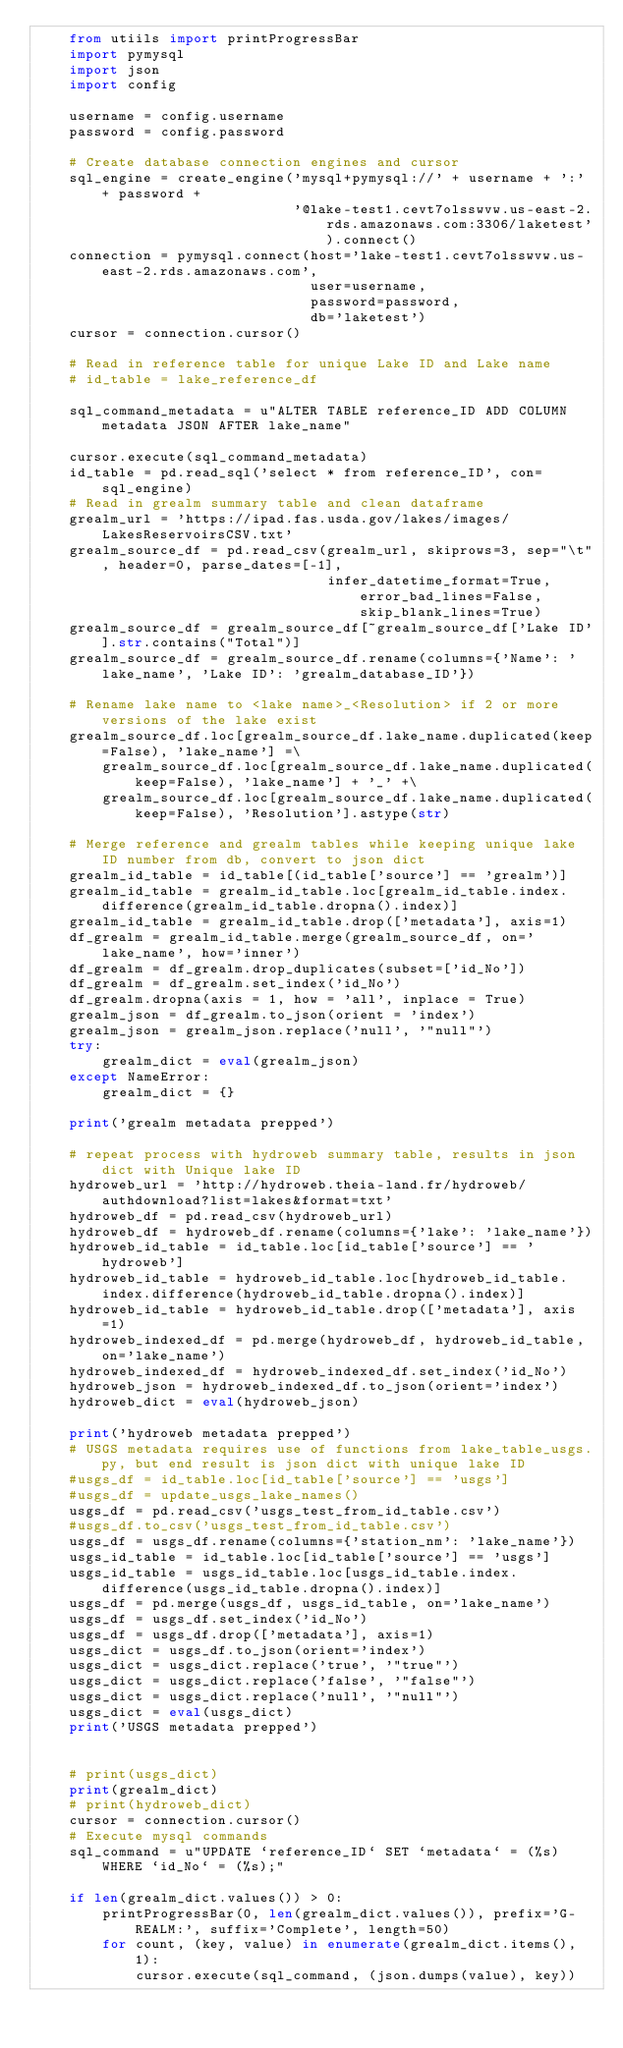<code> <loc_0><loc_0><loc_500><loc_500><_Python_>    from utiils import printProgressBar
    import pymysql
    import json
    import config

    username = config.username
    password = config.password

    # Create database connection engines and cursor
    sql_engine = create_engine('mysql+pymysql://' + username + ':' + password +
                               '@lake-test1.cevt7olsswvw.us-east-2.rds.amazonaws.com:3306/laketest').connect()
    connection = pymysql.connect(host='lake-test1.cevt7olsswvw.us-east-2.rds.amazonaws.com',
                                 user=username,
                                 password=password,
                                 db='laketest')
    cursor = connection.cursor()

    # Read in reference table for unique Lake ID and Lake name
    # id_table = lake_reference_df

    sql_command_metadata = u"ALTER TABLE reference_ID ADD COLUMN metadata JSON AFTER lake_name"

    cursor.execute(sql_command_metadata)
    id_table = pd.read_sql('select * from reference_ID', con=sql_engine)
    # Read in grealm summary table and clean dataframe
    grealm_url = 'https://ipad.fas.usda.gov/lakes/images/LakesReservoirsCSV.txt'
    grealm_source_df = pd.read_csv(grealm_url, skiprows=3, sep="\t", header=0, parse_dates=[-1],
                                   infer_datetime_format=True, error_bad_lines=False, skip_blank_lines=True)
    grealm_source_df = grealm_source_df[~grealm_source_df['Lake ID'].str.contains("Total")]
    grealm_source_df = grealm_source_df.rename(columns={'Name': 'lake_name', 'Lake ID': 'grealm_database_ID'})

    # Rename lake name to <lake name>_<Resolution> if 2 or more versions of the lake exist
    grealm_source_df.loc[grealm_source_df.lake_name.duplicated(keep=False), 'lake_name'] =\
        grealm_source_df.loc[grealm_source_df.lake_name.duplicated(keep=False), 'lake_name'] + '_' +\
        grealm_source_df.loc[grealm_source_df.lake_name.duplicated(keep=False), 'Resolution'].astype(str)

    # Merge reference and grealm tables while keeping unique lake ID number from db, convert to json dict
    grealm_id_table = id_table[(id_table['source'] == 'grealm')]
    grealm_id_table = grealm_id_table.loc[grealm_id_table.index.difference(grealm_id_table.dropna().index)]
    grealm_id_table = grealm_id_table.drop(['metadata'], axis=1)
    df_grealm = grealm_id_table.merge(grealm_source_df, on='lake_name', how='inner')
    df_grealm = df_grealm.drop_duplicates(subset=['id_No'])
    df_grealm = df_grealm.set_index('id_No')
    df_grealm.dropna(axis = 1, how = 'all', inplace = True)
    grealm_json = df_grealm.to_json(orient = 'index')
    grealm_json = grealm_json.replace('null', '"null"')
    try:
        grealm_dict = eval(grealm_json)
    except NameError:
        grealm_dict = {}

    print('grealm metadata prepped')

    # repeat process with hydroweb summary table, results in json dict with Unique lake ID
    hydroweb_url = 'http://hydroweb.theia-land.fr/hydroweb/authdownload?list=lakes&format=txt'
    hydroweb_df = pd.read_csv(hydroweb_url)
    hydroweb_df = hydroweb_df.rename(columns={'lake': 'lake_name'})
    hydroweb_id_table = id_table.loc[id_table['source'] == 'hydroweb']
    hydroweb_id_table = hydroweb_id_table.loc[hydroweb_id_table.index.difference(hydroweb_id_table.dropna().index)]
    hydroweb_id_table = hydroweb_id_table.drop(['metadata'], axis=1)
    hydroweb_indexed_df = pd.merge(hydroweb_df, hydroweb_id_table, on='lake_name')
    hydroweb_indexed_df = hydroweb_indexed_df.set_index('id_No')
    hydroweb_json = hydroweb_indexed_df.to_json(orient='index')
    hydroweb_dict = eval(hydroweb_json)

    print('hydroweb metadata prepped')
    # USGS metadata requires use of functions from lake_table_usgs.py, but end result is json dict with unique lake ID
    #usgs_df = id_table.loc[id_table['source'] == 'usgs']
    #usgs_df = update_usgs_lake_names()
    usgs_df = pd.read_csv('usgs_test_from_id_table.csv')
    #usgs_df.to_csv('usgs_test_from_id_table.csv')
    usgs_df = usgs_df.rename(columns={'station_nm': 'lake_name'})
    usgs_id_table = id_table.loc[id_table['source'] == 'usgs']
    usgs_id_table = usgs_id_table.loc[usgs_id_table.index.difference(usgs_id_table.dropna().index)]
    usgs_df = pd.merge(usgs_df, usgs_id_table, on='lake_name')
    usgs_df = usgs_df.set_index('id_No')
    usgs_df = usgs_df.drop(['metadata'], axis=1)
    usgs_dict = usgs_df.to_json(orient='index')
    usgs_dict = usgs_dict.replace('true', '"true"')
    usgs_dict = usgs_dict.replace('false', '"false"')
    usgs_dict = usgs_dict.replace('null', '"null"')
    usgs_dict = eval(usgs_dict)
    print('USGS metadata prepped')


    # print(usgs_dict)
    print(grealm_dict)
    # print(hydroweb_dict)
    cursor = connection.cursor()
    # Execute mysql commands
    sql_command = u"UPDATE `reference_ID` SET `metadata` = (%s) WHERE `id_No` = (%s);"

    if len(grealm_dict.values()) > 0:
        printProgressBar(0, len(grealm_dict.values()), prefix='G-REALM:', suffix='Complete', length=50)
        for count, (key, value) in enumerate(grealm_dict.items(), 1):
            cursor.execute(sql_command, (json.dumps(value), key))</code> 